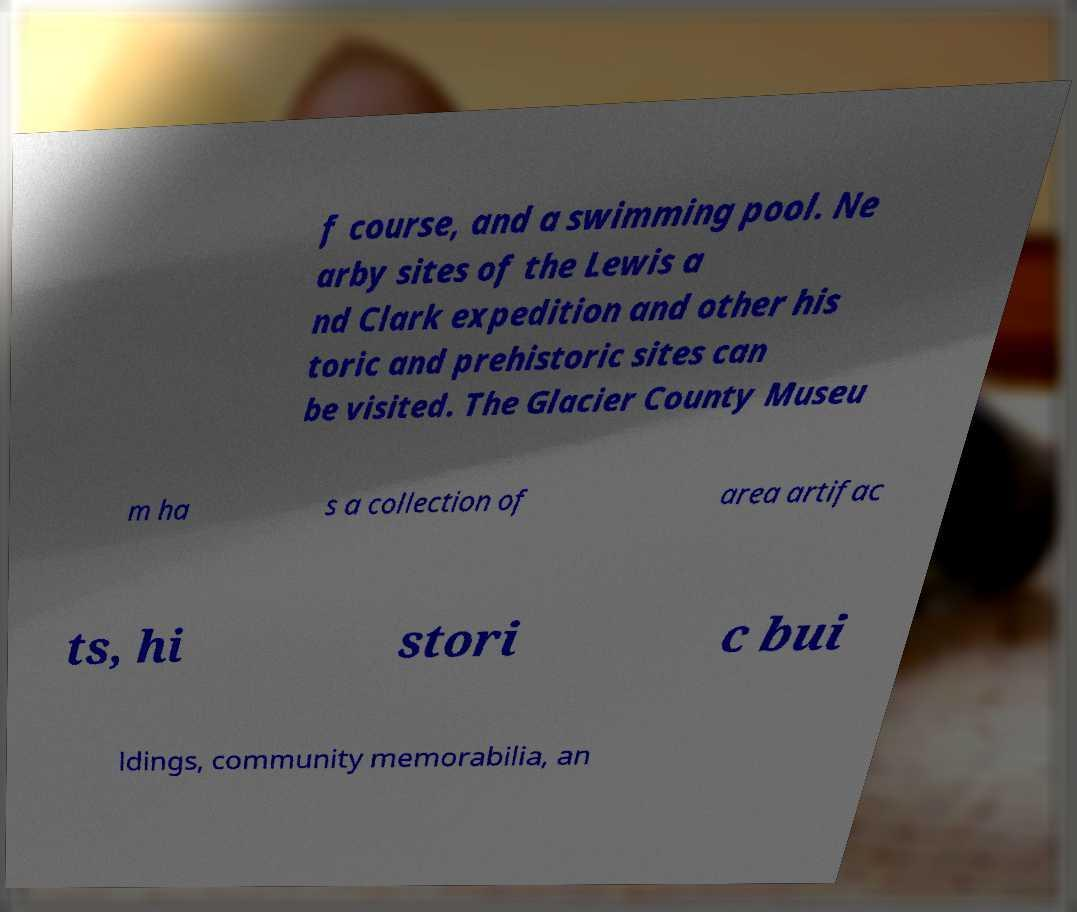There's text embedded in this image that I need extracted. Can you transcribe it verbatim? f course, and a swimming pool. Ne arby sites of the Lewis a nd Clark expedition and other his toric and prehistoric sites can be visited. The Glacier County Museu m ha s a collection of area artifac ts, hi stori c bui ldings, community memorabilia, an 